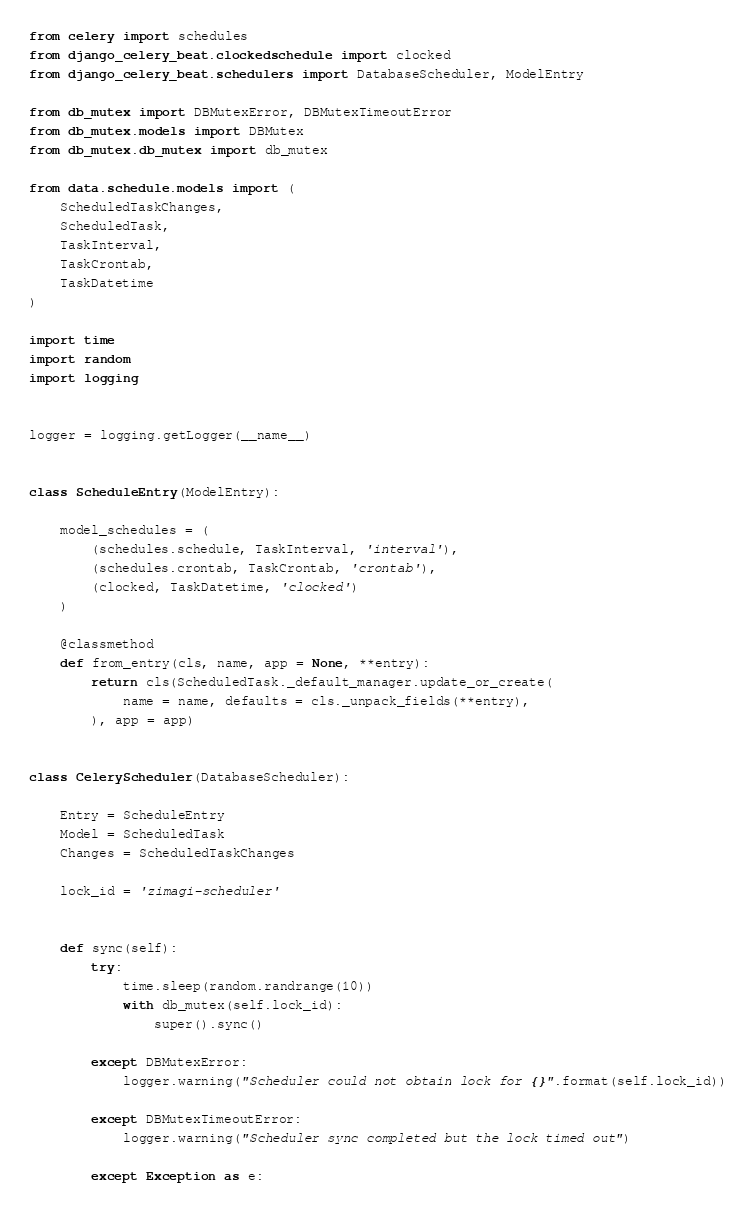Convert code to text. <code><loc_0><loc_0><loc_500><loc_500><_Python_>from celery import schedules
from django_celery_beat.clockedschedule import clocked
from django_celery_beat.schedulers import DatabaseScheduler, ModelEntry

from db_mutex import DBMutexError, DBMutexTimeoutError
from db_mutex.models import DBMutex
from db_mutex.db_mutex import db_mutex

from data.schedule.models import (
    ScheduledTaskChanges,
    ScheduledTask,
    TaskInterval,
    TaskCrontab,
    TaskDatetime
)

import time
import random
import logging


logger = logging.getLogger(__name__)


class ScheduleEntry(ModelEntry):

    model_schedules = (
        (schedules.schedule, TaskInterval, 'interval'),
        (schedules.crontab, TaskCrontab, 'crontab'),
        (clocked, TaskDatetime, 'clocked')
    )

    @classmethod
    def from_entry(cls, name, app = None, **entry):
        return cls(ScheduledTask._default_manager.update_or_create(
            name = name, defaults = cls._unpack_fields(**entry),
        ), app = app)


class CeleryScheduler(DatabaseScheduler):

    Entry = ScheduleEntry
    Model = ScheduledTask
    Changes = ScheduledTaskChanges

    lock_id = 'zimagi-scheduler'


    def sync(self):
        try:
            time.sleep(random.randrange(10))
            with db_mutex(self.lock_id):
                super().sync()

        except DBMutexError:
            logger.warning("Scheduler could not obtain lock for {}".format(self.lock_id))

        except DBMutexTimeoutError:
            logger.warning("Scheduler sync completed but the lock timed out")

        except Exception as e:</code> 